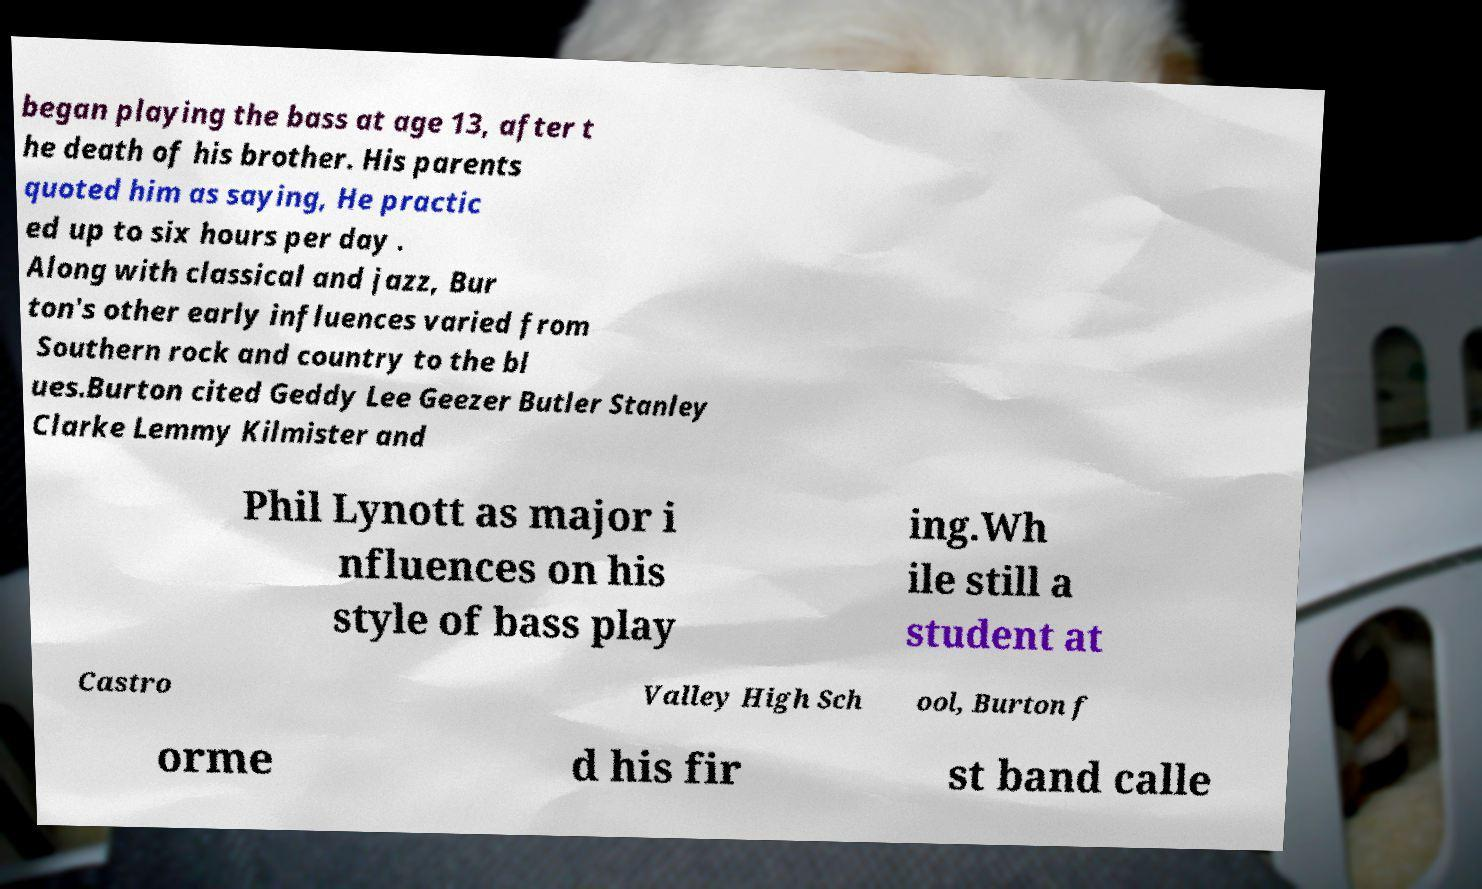There's text embedded in this image that I need extracted. Can you transcribe it verbatim? began playing the bass at age 13, after t he death of his brother. His parents quoted him as saying, He practic ed up to six hours per day . Along with classical and jazz, Bur ton's other early influences varied from Southern rock and country to the bl ues.Burton cited Geddy Lee Geezer Butler Stanley Clarke Lemmy Kilmister and Phil Lynott as major i nfluences on his style of bass play ing.Wh ile still a student at Castro Valley High Sch ool, Burton f orme d his fir st band calle 